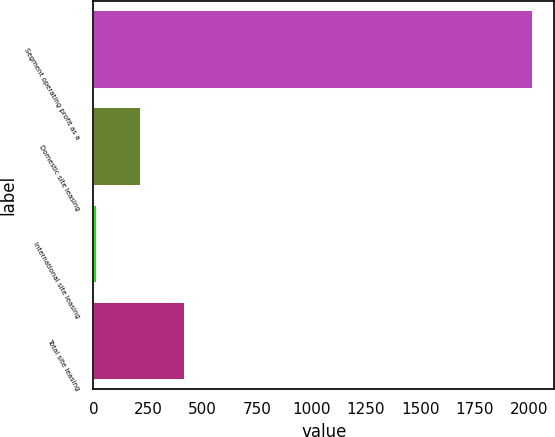Convert chart to OTSL. <chart><loc_0><loc_0><loc_500><loc_500><bar_chart><fcel>Segment operating profit as a<fcel>Domestic site leasing<fcel>International site leasing<fcel>Total site leasing<nl><fcel>2015<fcel>214.46<fcel>14.4<fcel>414.52<nl></chart> 